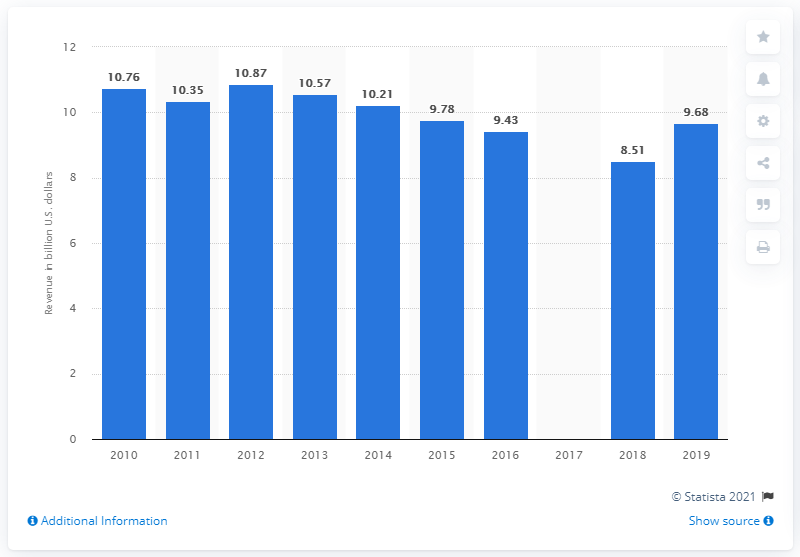Give some essential details in this illustration. In 2019, U.S. publishers generated approximately 9.68 billion dollars in revenue from subscriptions and sales of periodicals. In 2018, the total revenue of periodicals in the United States was 8.51 billion dollars. 